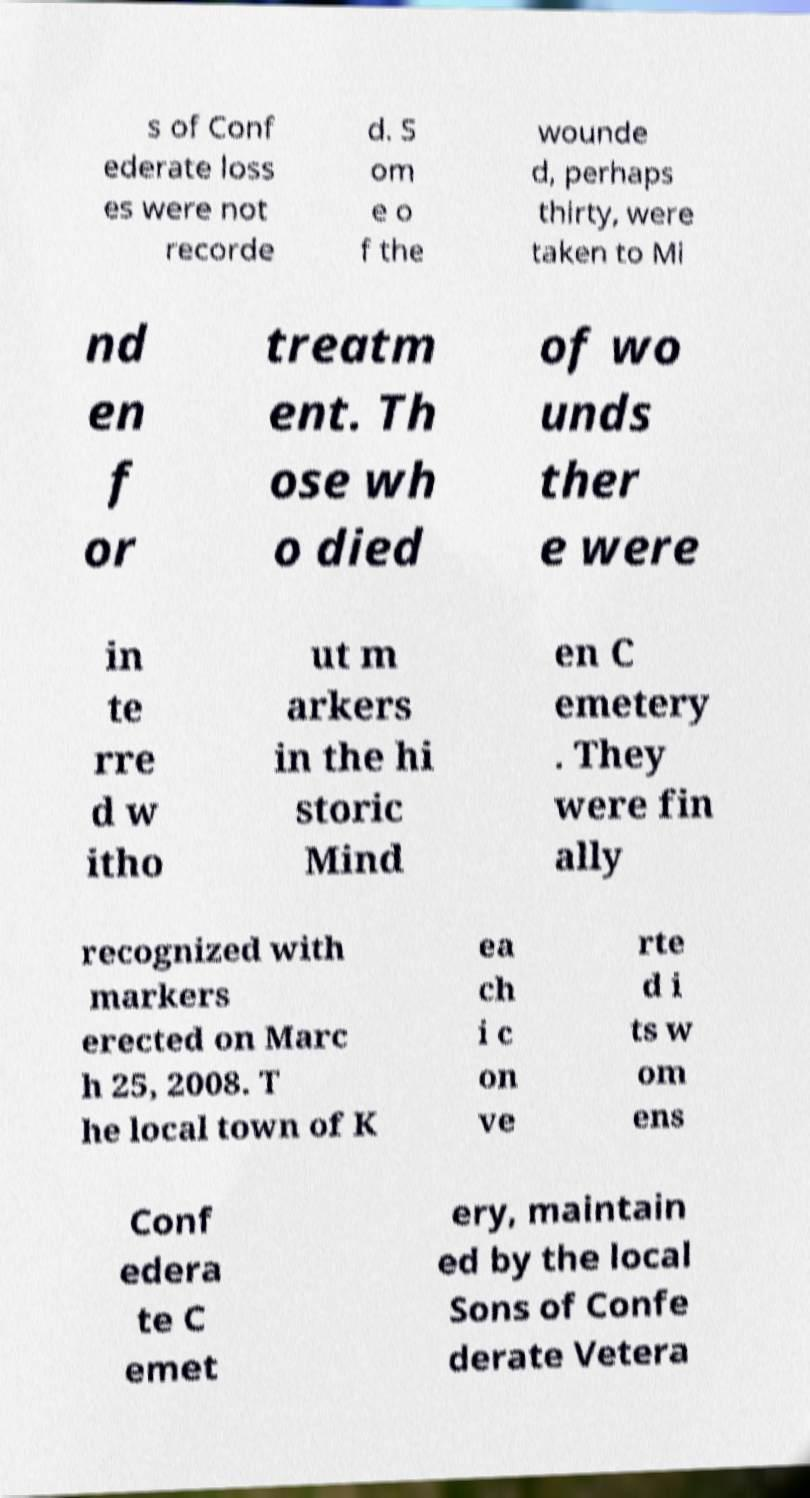What messages or text are displayed in this image? I need them in a readable, typed format. s of Conf ederate loss es were not recorde d. S om e o f the wounde d, perhaps thirty, were taken to Mi nd en f or treatm ent. Th ose wh o died of wo unds ther e were in te rre d w itho ut m arkers in the hi storic Mind en C emetery . They were fin ally recognized with markers erected on Marc h 25, 2008. T he local town of K ea ch i c on ve rte d i ts w om ens Conf edera te C emet ery, maintain ed by the local Sons of Confe derate Vetera 